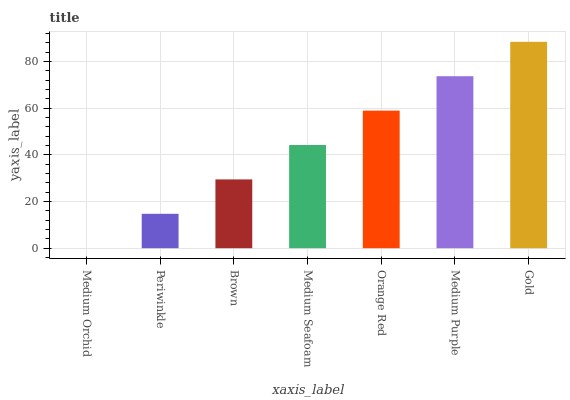Is Medium Orchid the minimum?
Answer yes or no. Yes. Is Gold the maximum?
Answer yes or no. Yes. Is Periwinkle the minimum?
Answer yes or no. No. Is Periwinkle the maximum?
Answer yes or no. No. Is Periwinkle greater than Medium Orchid?
Answer yes or no. Yes. Is Medium Orchid less than Periwinkle?
Answer yes or no. Yes. Is Medium Orchid greater than Periwinkle?
Answer yes or no. No. Is Periwinkle less than Medium Orchid?
Answer yes or no. No. Is Medium Seafoam the high median?
Answer yes or no. Yes. Is Medium Seafoam the low median?
Answer yes or no. Yes. Is Medium Purple the high median?
Answer yes or no. No. Is Gold the low median?
Answer yes or no. No. 